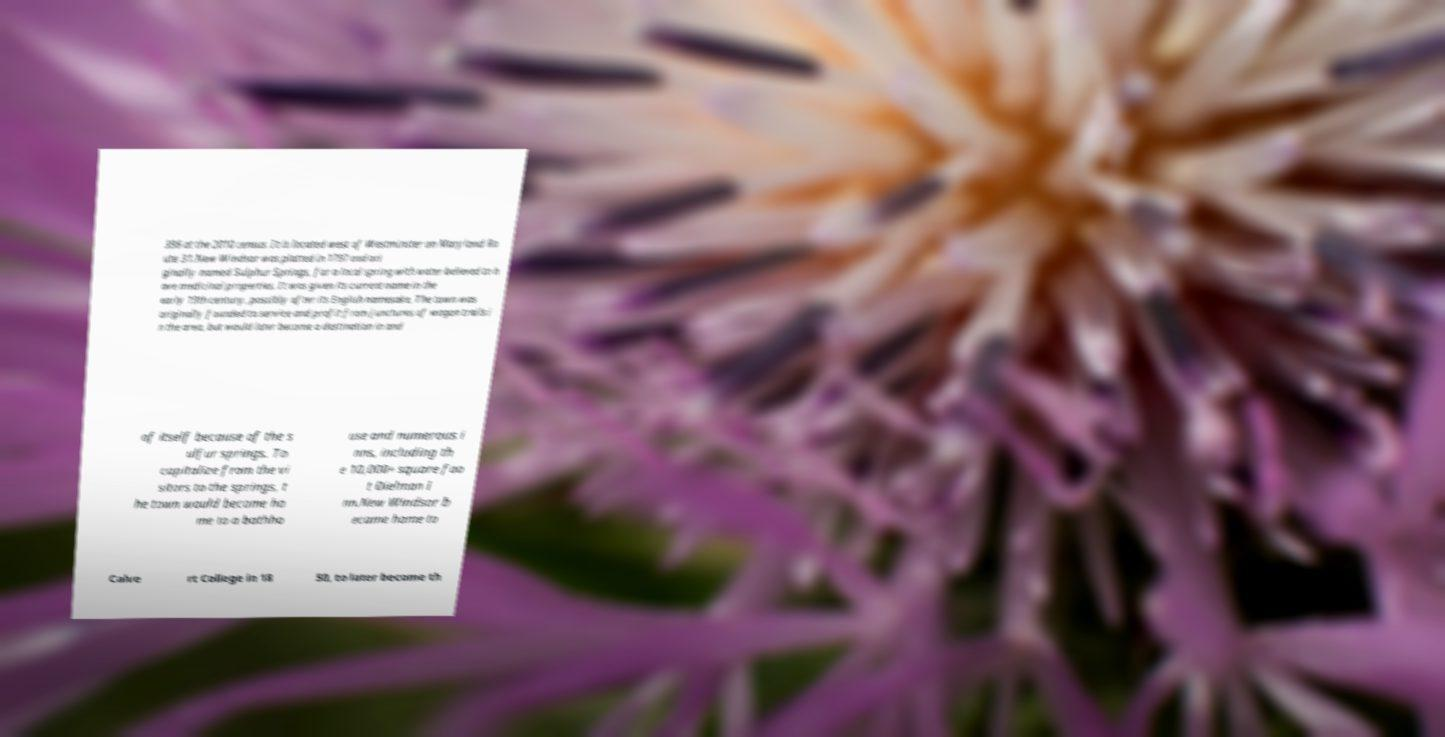Please read and relay the text visible in this image. What does it say? 396 at the 2010 census. It is located west of Westminster on Maryland Ro ute 31.New Windsor was platted in 1797 and ori ginally named Sulphur Springs, for a local spring with water believed to h ave medicinal properties. It was given its current name in the early 19th century, possibly after its English namesake. The town was originally founded to service and profit from junctures of wagon trails i n the area, but would later become a destination in and of itself because of the s ulfur springs. To capitalize from the vi sitors to the springs, t he town would become ho me to a bathho use and numerous i nns, including th e 10,000+ square foo t Dielman I nn.New Windsor b ecame home to Calve rt College in 18 50, to later become th 